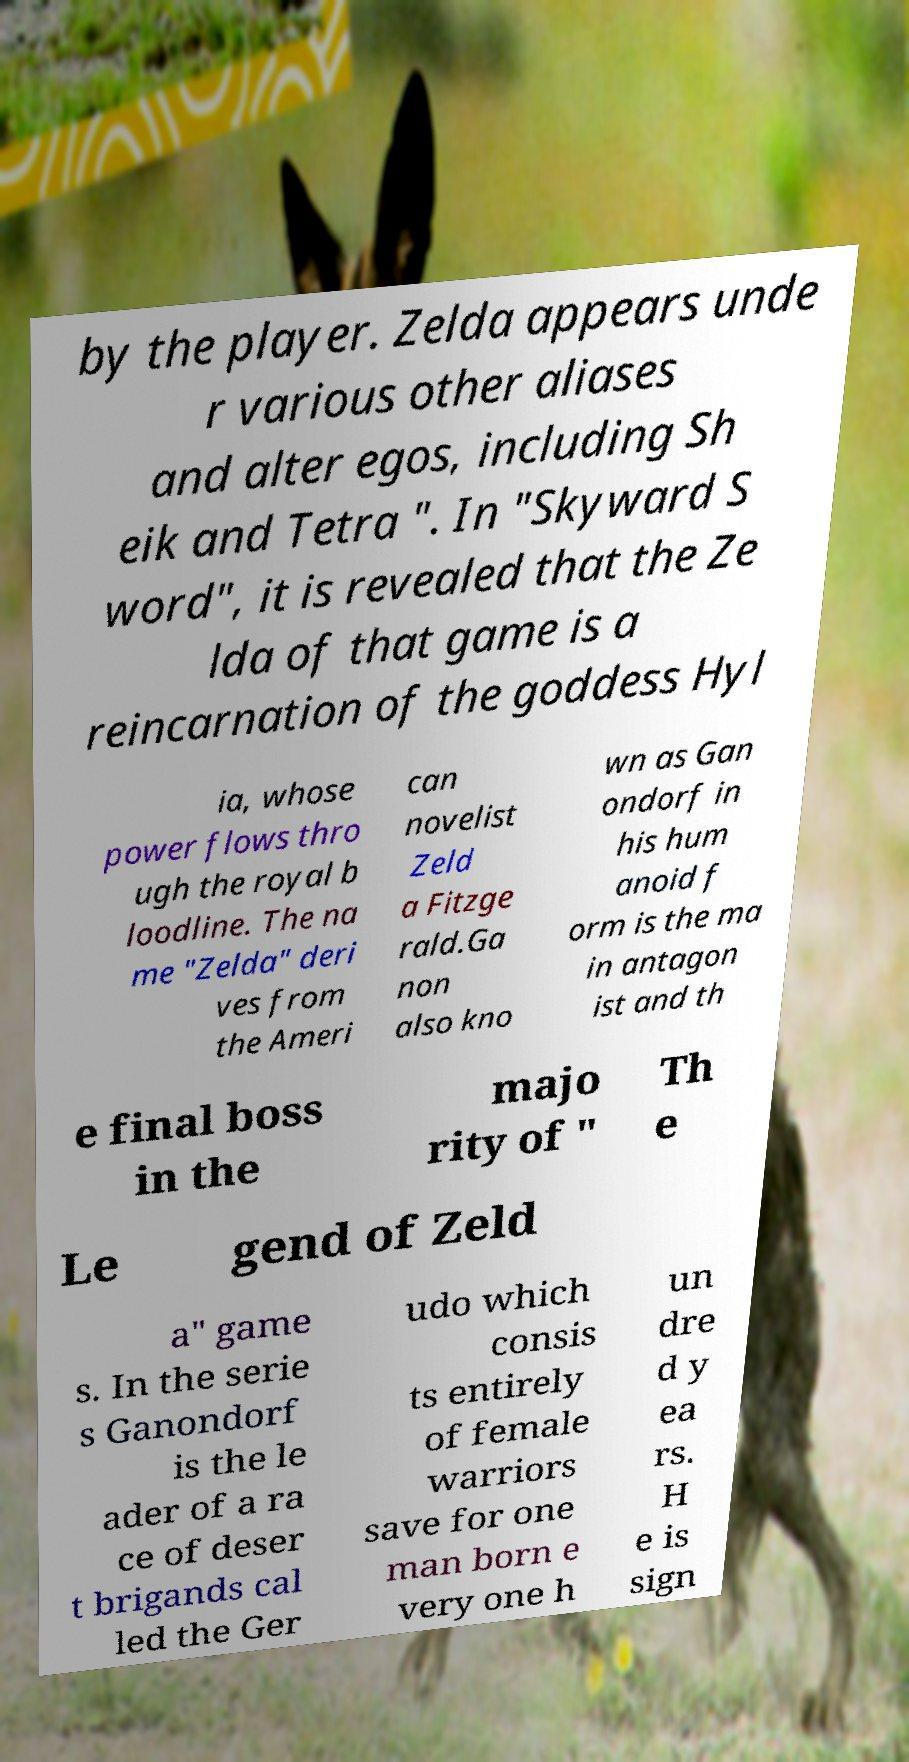I need the written content from this picture converted into text. Can you do that? by the player. Zelda appears unde r various other aliases and alter egos, including Sh eik and Tetra ". In "Skyward S word", it is revealed that the Ze lda of that game is a reincarnation of the goddess Hyl ia, whose power flows thro ugh the royal b loodline. The na me "Zelda" deri ves from the Ameri can novelist Zeld a Fitzge rald.Ga non also kno wn as Gan ondorf in his hum anoid f orm is the ma in antagon ist and th e final boss in the majo rity of " Th e Le gend of Zeld a" game s. In the serie s Ganondorf is the le ader of a ra ce of deser t brigands cal led the Ger udo which consis ts entirely of female warriors save for one man born e very one h un dre d y ea rs. H e is sign 